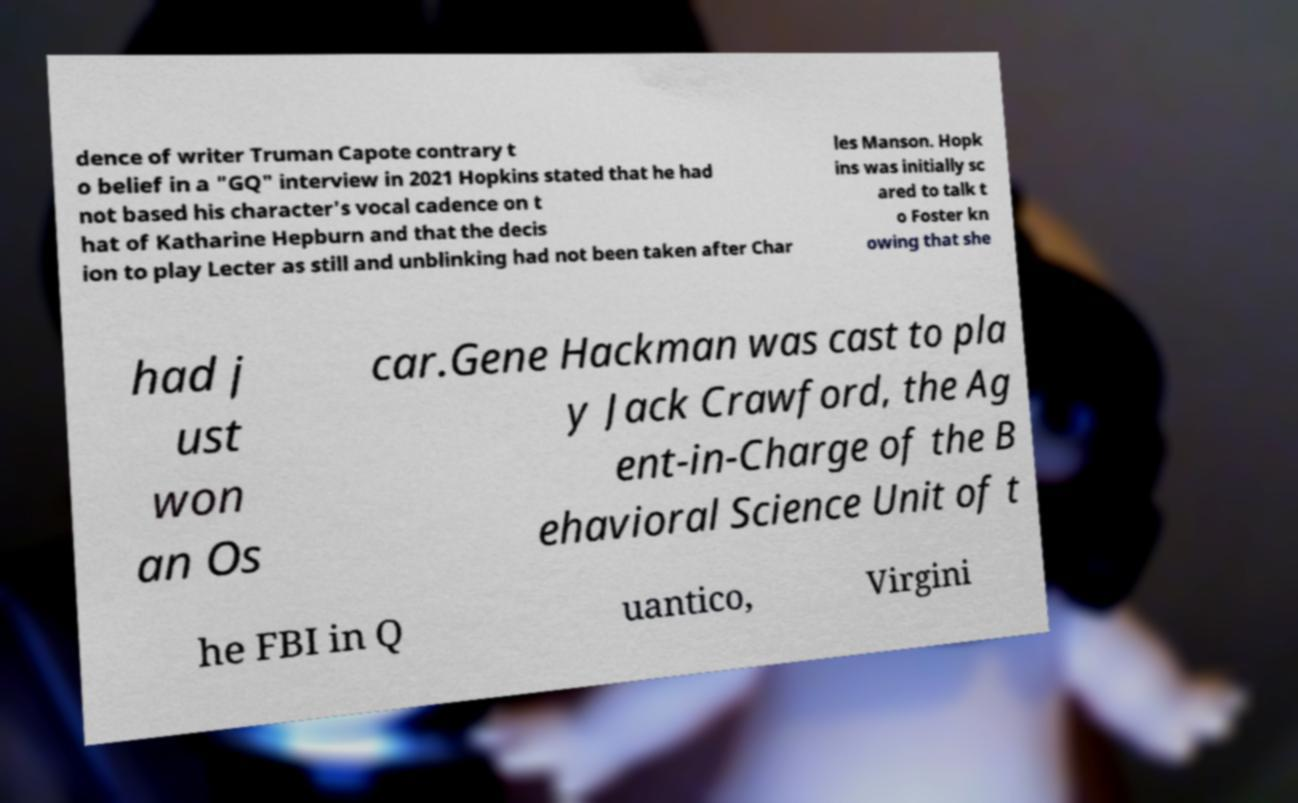I need the written content from this picture converted into text. Can you do that? dence of writer Truman Capote contrary t o belief in a "GQ" interview in 2021 Hopkins stated that he had not based his character's vocal cadence on t hat of Katharine Hepburn and that the decis ion to play Lecter as still and unblinking had not been taken after Char les Manson. Hopk ins was initially sc ared to talk t o Foster kn owing that she had j ust won an Os car.Gene Hackman was cast to pla y Jack Crawford, the Ag ent-in-Charge of the B ehavioral Science Unit of t he FBI in Q uantico, Virgini 